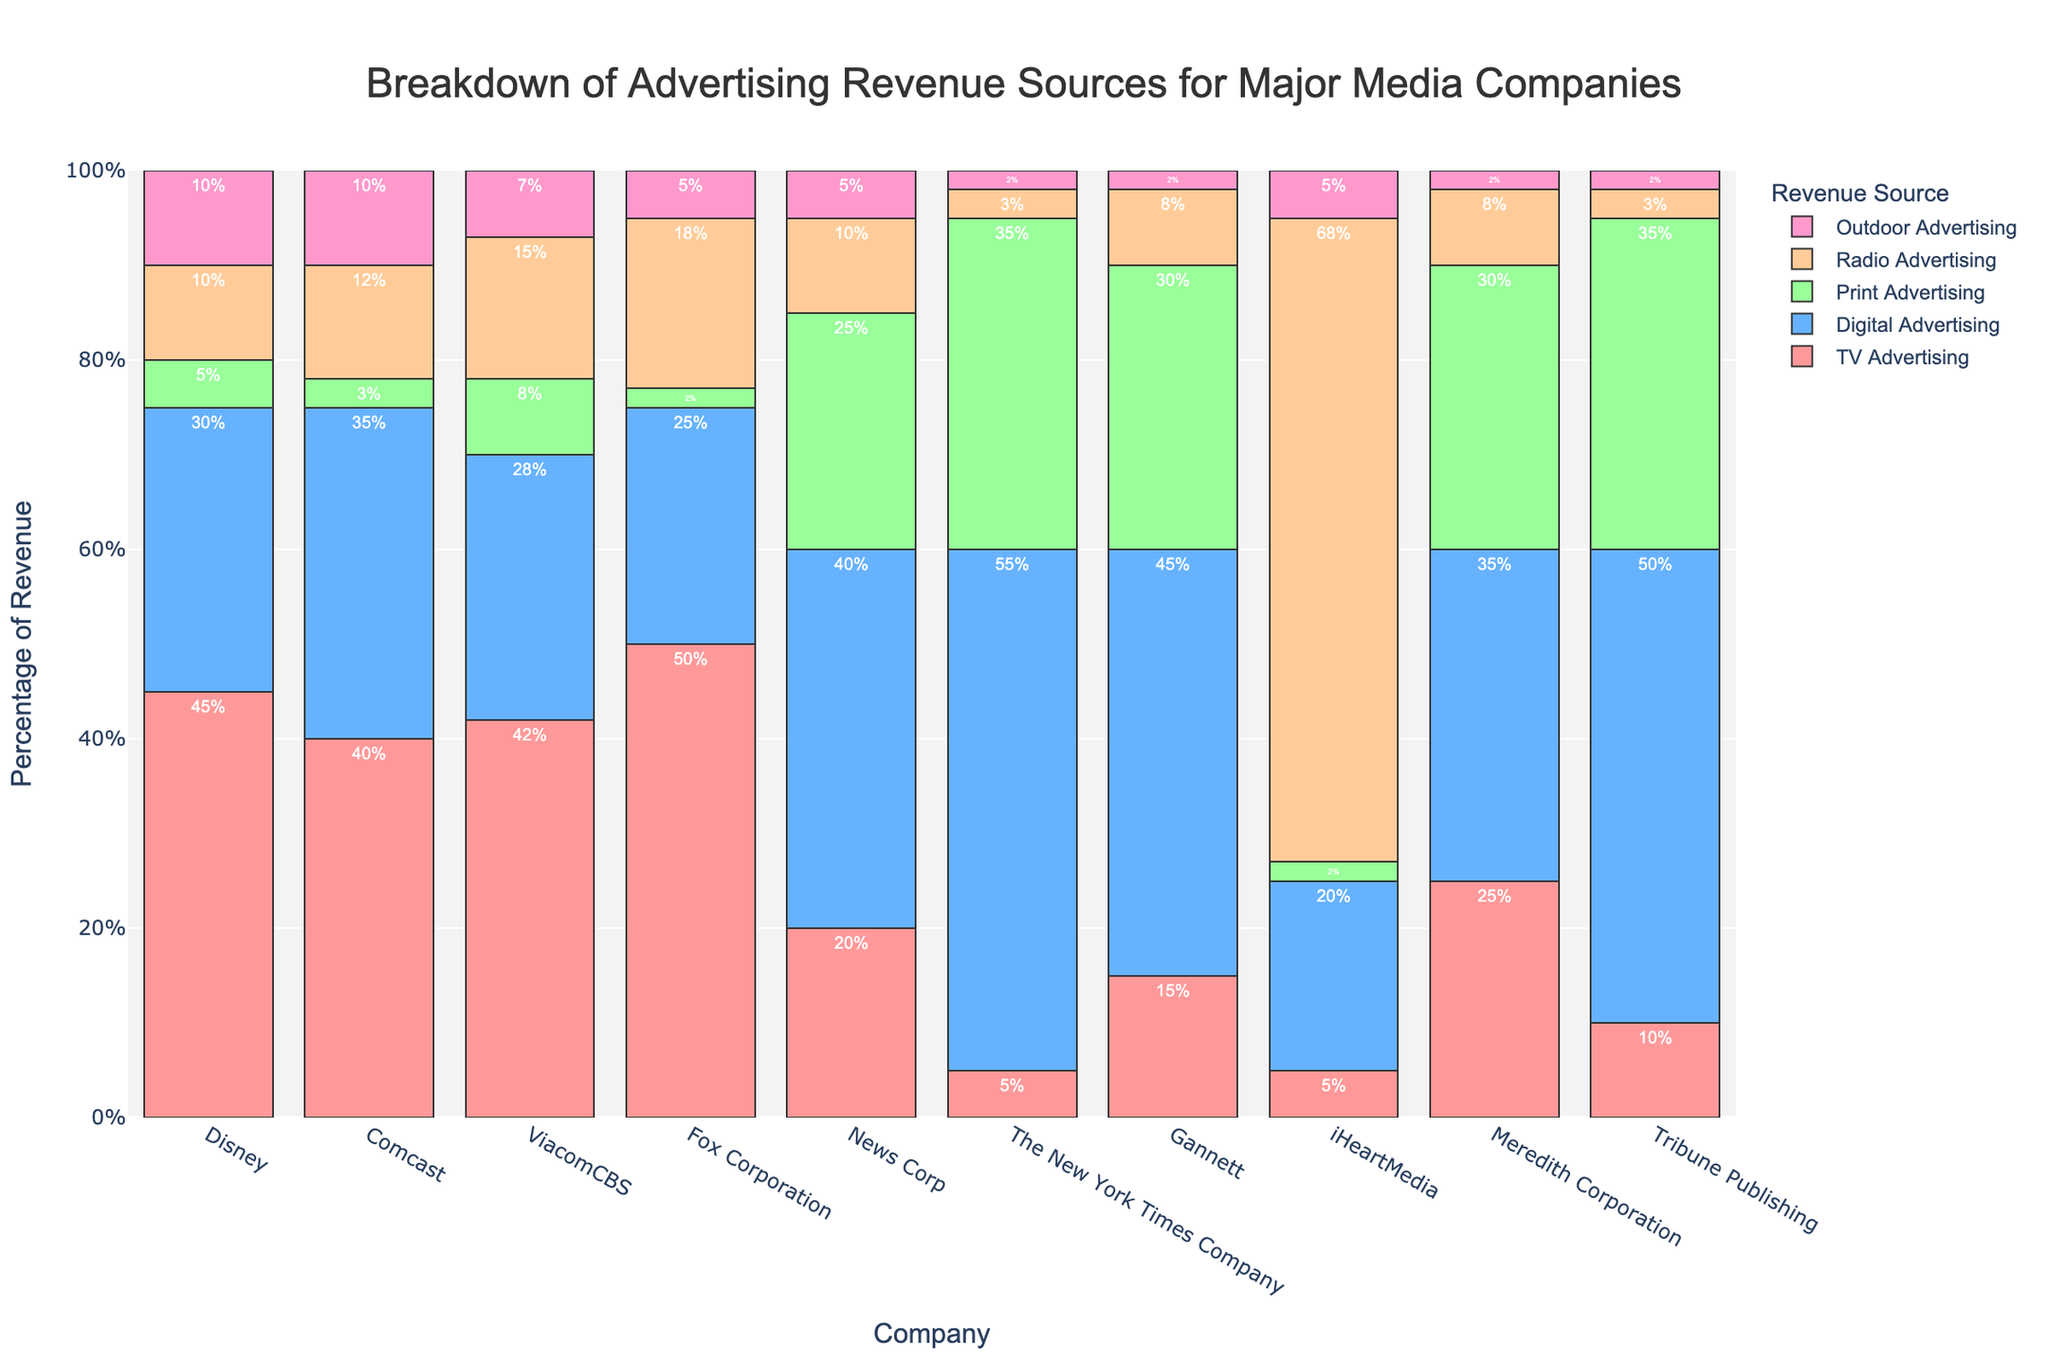Which company has the highest percentage of revenue from TV Advertising? The highest percentage of revenue from TV Advertising is represented by the tallest bar in the TV Advertising category. Fox Corporation's bar is the tallest.
Answer: Fox Corporation Which company generates the most revenue from Digital Advertising compared to others? The company with the tallest bar in the Digital Advertising category generates the most revenue from it. The New York Times Company has the tallest bar for Digital Advertising.
Answer: The New York Times Company What is the difference in percentage between TV Advertising and Digital Advertising for Disney? For Disney, TV Advertising is 45% and Digital Advertising is 30%. The difference is found by subtracting the smaller percentage from the larger one: 45% - 30% = 15%.
Answer: 15% Which media company has the least percentage of revenue from Print Advertising? The lowest bar in the Print Advertising category indicates the company with the least percentage of revenue from it. Fox Corporation has the smallest bar, indicating 2%.
Answer: Fox Corporation What is the combined percentage of revenue from Radio Advertising and Outdoor Advertising for iHeartMedia? For iHeartMedia, Radio Advertising is 68% and Outdoor Advertising is 5%. Adding these percentages together: 68% + 5% = 73%.
Answer: 73% Which company has an equal percentage of revenue from both Radio Advertising and Outdoor Advertising? By visually comparing the bars within the Radio Advertising and Outdoor Advertising categories, we see that Disney has 10% in both categories.
Answer: Disney For Meredith Corporation, what is the total percentage of revenue from Print Advertising and Digital Advertising? For Meredith Corporation, Print Advertising is 30% and Digital Advertising is 35%. Adding these up: 30% + 35% = 65%.
Answer: 65% How does the percentage of TV Advertising for News Corp compare to The New York Times Company? For TV Advertising, News Corp has 20% and The New York Times Company has 5%. Comparing these values, News Corp has a higher percentage.
Answer: News Corp has a higher percentage What's the average percentage of revenue from Outdoor Advertising for all companies? Summing Outdoor Advertising percentages for all companies: 10 + 10 + 7 + 5 + 5 + 2 + 2 + 5 + 2 + 2 = 50%. There are 10 companies, so the average is 50% / 10 = 5%.
Answer: 5% Which company has the most evenly distributed (least variation across) advertising sources and which has the most varied based on the bar lengths? By visually inspecting the bars' heights for evenness, Gannett appears relatively balanced, while iHeartMedia shows a significant variance with a very tall bar for Radio Advertising and shorter bars for others.
Answer: Most evenly: Gannett, Most varied: iHeartMedia 